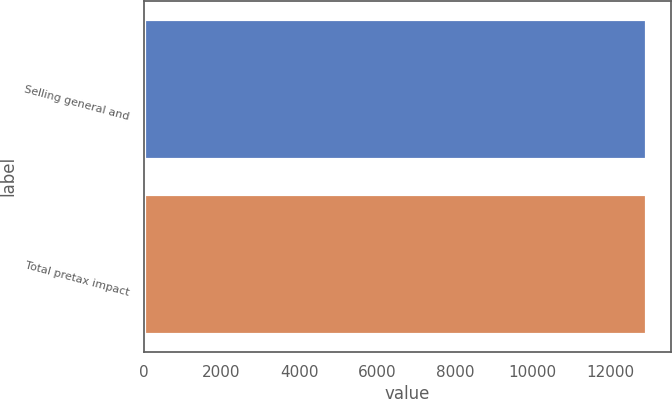<chart> <loc_0><loc_0><loc_500><loc_500><bar_chart><fcel>Selling general and<fcel>Total pretax impact<nl><fcel>12908<fcel>12908.1<nl></chart> 